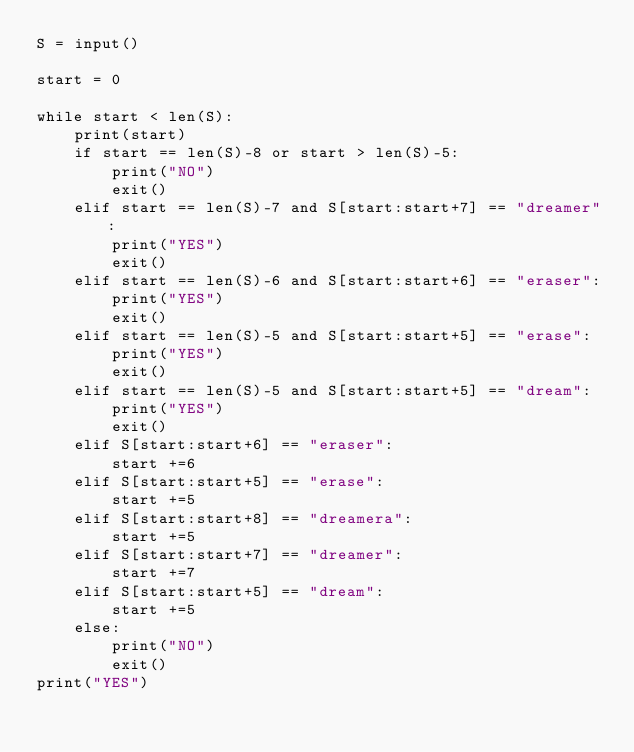Convert code to text. <code><loc_0><loc_0><loc_500><loc_500><_Python_>S = input()

start = 0

while start < len(S):
    print(start)
    if start == len(S)-8 or start > len(S)-5:
        print("NO")
        exit()
    elif start == len(S)-7 and S[start:start+7] == "dreamer":
        print("YES")
        exit()
    elif start == len(S)-6 and S[start:start+6] == "eraser":
        print("YES")
        exit()
    elif start == len(S)-5 and S[start:start+5] == "erase":
        print("YES")
        exit()
    elif start == len(S)-5 and S[start:start+5] == "dream":
        print("YES")
        exit()
    elif S[start:start+6] == "eraser":
        start +=6
    elif S[start:start+5] == "erase":
        start +=5
    elif S[start:start+8] == "dreamera":
        start +=5
    elif S[start:start+7] == "dreamer":
        start +=7
    elif S[start:start+5] == "dream":
        start +=5
    else:
        print("NO")
        exit()
print("YES")</code> 